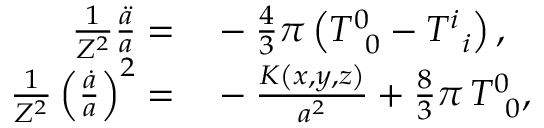Convert formula to latex. <formula><loc_0><loc_0><loc_500><loc_500>\begin{array} { r l } { \frac { 1 } { Z ^ { 2 } } \frac { \ddot { a } } { a } = } & - \frac { 4 } { 3 } \pi \left ( T _ { \, 0 } ^ { 0 } - T _ { \, i } ^ { i } \right ) , } \\ { \frac { 1 } { Z ^ { 2 } } \left ( \frac { \dot { a } } { a } \right ) ^ { 2 } = } & - \frac { K \left ( x , y , z \right ) } { a ^ { 2 } } + \frac { 8 } { 3 } \pi \, T _ { \, 0 } ^ { 0 } , } \end{array}</formula> 